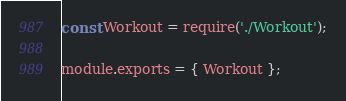<code> <loc_0><loc_0><loc_500><loc_500><_JavaScript_>const Workout = require('./Workout');

module.exports = { Workout };</code> 